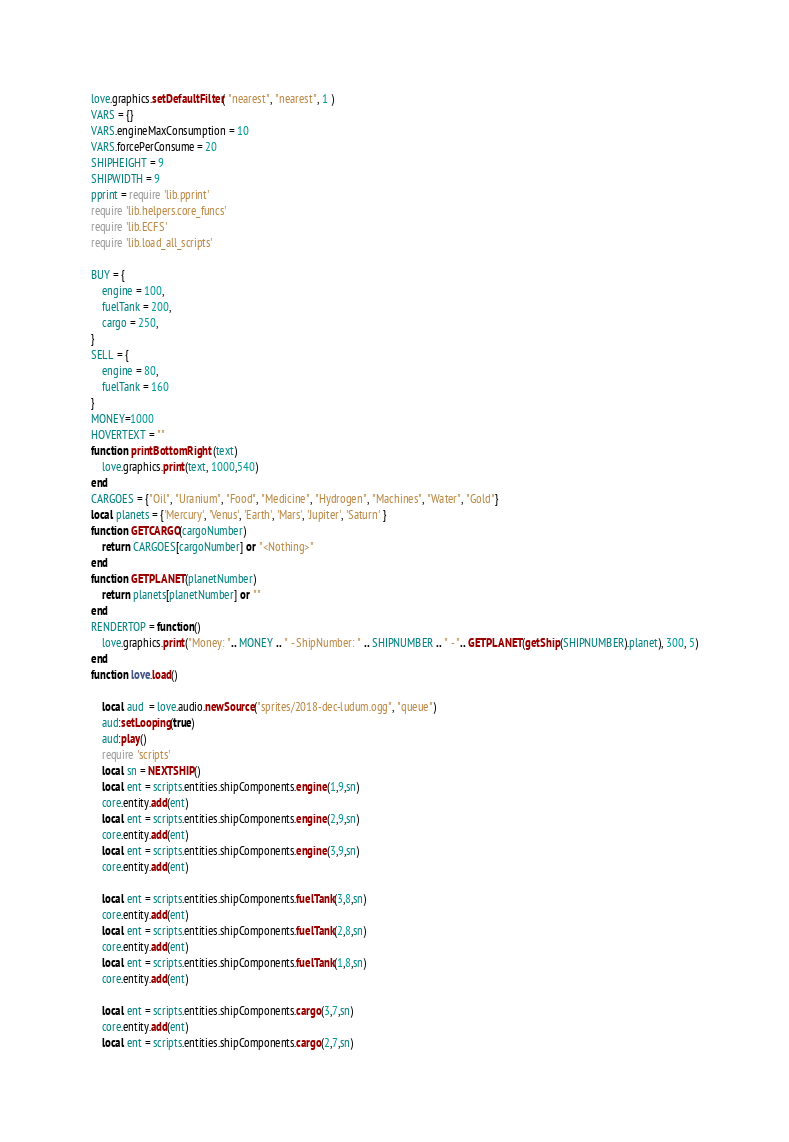<code> <loc_0><loc_0><loc_500><loc_500><_Lua_>love.graphics.setDefaultFilter( "nearest", "nearest", 1 )
VARS = {}
VARS.engineMaxConsumption = 10
VARS.forcePerConsume = 20
SHIPHEIGHT = 9
SHIPWIDTH = 9
pprint = require 'lib.pprint'
require 'lib.helpers.core_funcs'
require 'lib.ECFS'
require 'lib.load_all_scripts'

BUY = {
    engine = 100,
    fuelTank = 200,
    cargo = 250,
}
SELL = {
    engine = 80,
    fuelTank = 160
}
MONEY=1000
HOVERTEXT = ""
function printBottomRight (text)
    love.graphics.print(text, 1000,540)
end
CARGOES = {"Oil", "Uranium", "Food", "Medicine", "Hydrogen", "Machines", "Water", "Gold"}
local planets = {'Mercury', 'Venus', 'Earth', 'Mars', 'Jupiter', 'Saturn' }
function GETCARGO(cargoNumber)
    return CARGOES[cargoNumber] or "<Nothing>"
end
function GETPLANET(planetNumber)
    return planets[planetNumber] or ""
end
RENDERTOP = function()
    love.graphics.print("Money: ".. MONEY .. " - ShipNumber: " .. SHIPNUMBER .. " - ".. GETPLANET(getShip(SHIPNUMBER).planet), 300, 5)
end
function love.load()

    local aud  = love.audio.newSource("sprites/2018-dec-ludum.ogg", "queue")
    aud:setLooping(true)
    aud:play()
    require 'scripts'
    local sn = NEXTSHIP()
    local ent = scripts.entities.shipComponents.engine(1,9,sn)
    core.entity.add(ent)
    local ent = scripts.entities.shipComponents.engine(2,9,sn)
    core.entity.add(ent)
    local ent = scripts.entities.shipComponents.engine(3,9,sn)
    core.entity.add(ent)

    local ent = scripts.entities.shipComponents.fuelTank(3,8,sn)
    core.entity.add(ent)
    local ent = scripts.entities.shipComponents.fuelTank(2,8,sn)
    core.entity.add(ent)
    local ent = scripts.entities.shipComponents.fuelTank(1,8,sn)
    core.entity.add(ent)

    local ent = scripts.entities.shipComponents.cargo(3,7,sn)
    core.entity.add(ent)
    local ent = scripts.entities.shipComponents.cargo(2,7,sn)</code> 